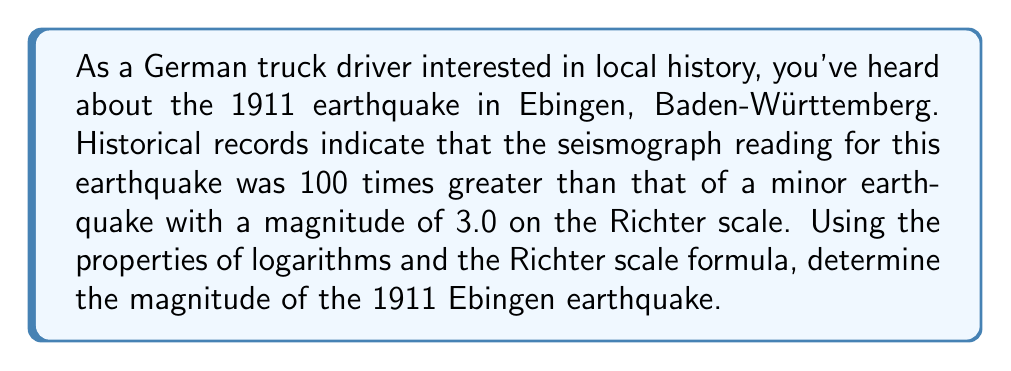Solve this math problem. Let's approach this step-by-step:

1) The Richter scale is logarithmic and is defined by the equation:

   $$ M = \log_{10}(A) - \log_{10}(A_0) $$

   Where $M$ is the magnitude, $A$ is the maximum amplitude measured, and $A_0$ is a standard reference amplitude.

2) We're told that the amplitude of the Ebingen earthquake was 100 times greater than a magnitude 3.0 earthquake. Let's call the amplitude of the 3.0 earthquake $A_1$ and the Ebingen earthquake $A_2$.

   $$ A_2 = 100A_1 $$

3) We know the magnitude of the smaller earthquake is 3.0. Let's use this in the Richter scale equation:

   $$ 3.0 = \log_{10}(A_1) - \log_{10}(A_0) $$

4) For the Ebingen earthquake:

   $$ M_2 = \log_{10}(A_2) - \log_{10}(A_0) $$

5) Subtracting these equations:

   $$ M_2 - 3.0 = \log_{10}(A_2) - \log_{10}(A_1) $$

6) Using the logarithm property $\log_a(x) - \log_a(y) = \log_a(\frac{x}{y})$:

   $$ M_2 - 3.0 = \log_{10}(\frac{A_2}{A_1}) = \log_{10}(100) = 2 $$

7) Solving for $M_2$:

   $$ M_2 = 3.0 + 2 = 5.0 $$

Therefore, the magnitude of the 1911 Ebingen earthquake was 5.0 on the Richter scale.
Answer: 5.0 